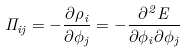<formula> <loc_0><loc_0><loc_500><loc_500>\Pi _ { i j } = - \frac { \partial \rho _ { i } } { \partial \phi _ { j } } = - \frac { \partial ^ { 2 } E } { \partial \phi _ { i } \partial \phi _ { j } }</formula> 